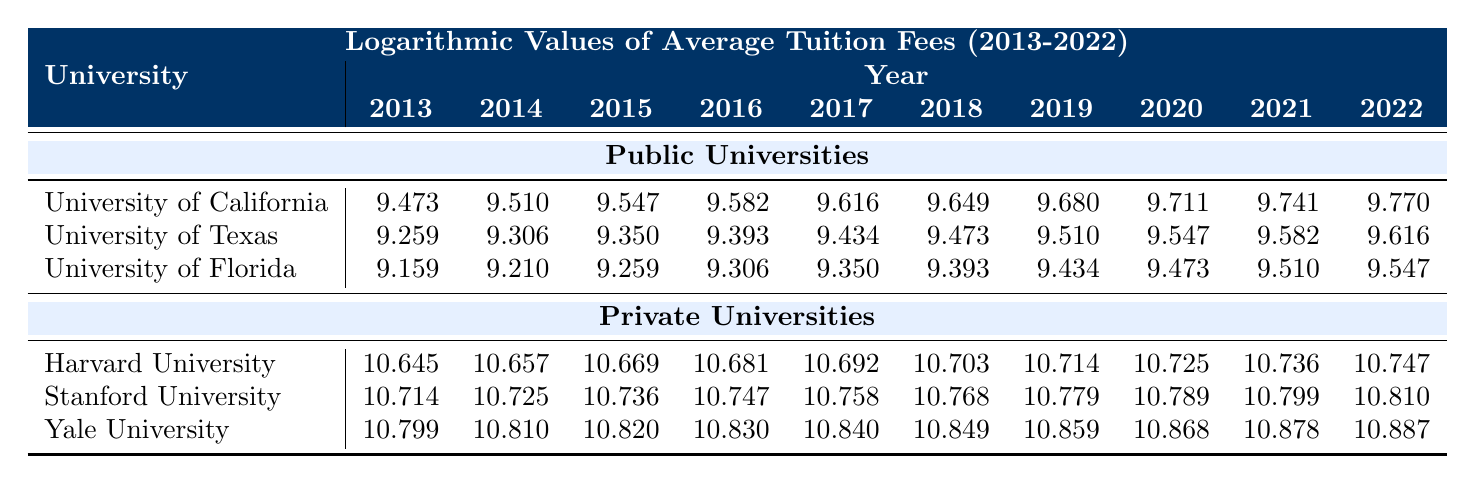What was the tuition fee for the University of Texas in 2018? Referring to the table, the entry for the University of Texas in the year 2018 is provided. The value listed is 9.473 (logarithmic value).
Answer: 9.473 Which university had the highest tuition fee in 2020? By looking at the values in the table for the year 2020, we can compare the logarithmic values of all universities. Harvard University has a value of 10.725, Stanford University has 10.789, and Yale University has 10.868. Therefore, Yale University has the highest tuition fee for that year.
Answer: Yale University What is the average tuition fee for the University of California over the decade? To find the average, we sum the logarithmic values from 2013 to 2022 (9.473 + 9.510 + 9.547 + 9.582 + 9.616 + 9.649 + 9.680 + 9.711 + 9.741 + 9.770 = 96.728) and divide by 10. This gives an average of 96.728 / 10 = 9.6728.
Answer: 9.6728 Is the average tuition fee at public universities consistently lower than that at private universities from 2013 to 2022? We can observe the yearly average for both types of universities across the given years. Public universities' averages (from the lowest being 9.159 for University of Florida to 9.770 for University of California) and private universities' averages (from 10.645 for Harvard to 10.887 for Yale) indicate that public university fees are lower in every year. Thus, it can be concluded that public university average fees are consistently lower.
Answer: Yes In which year did Stanford University's tuition fees exceed Harvard University's fees? By examining the values from the years provided, we note that Stanford University's fees start at 10.714 in 2013, which is less than Harvard's fees of 10.645. However, after 2014, we can find that Stanford's fees exceed Harvard's fees starting from 2017 (10.758 for Stanford vs. 10.692 for Harvard).
Answer: 2017 